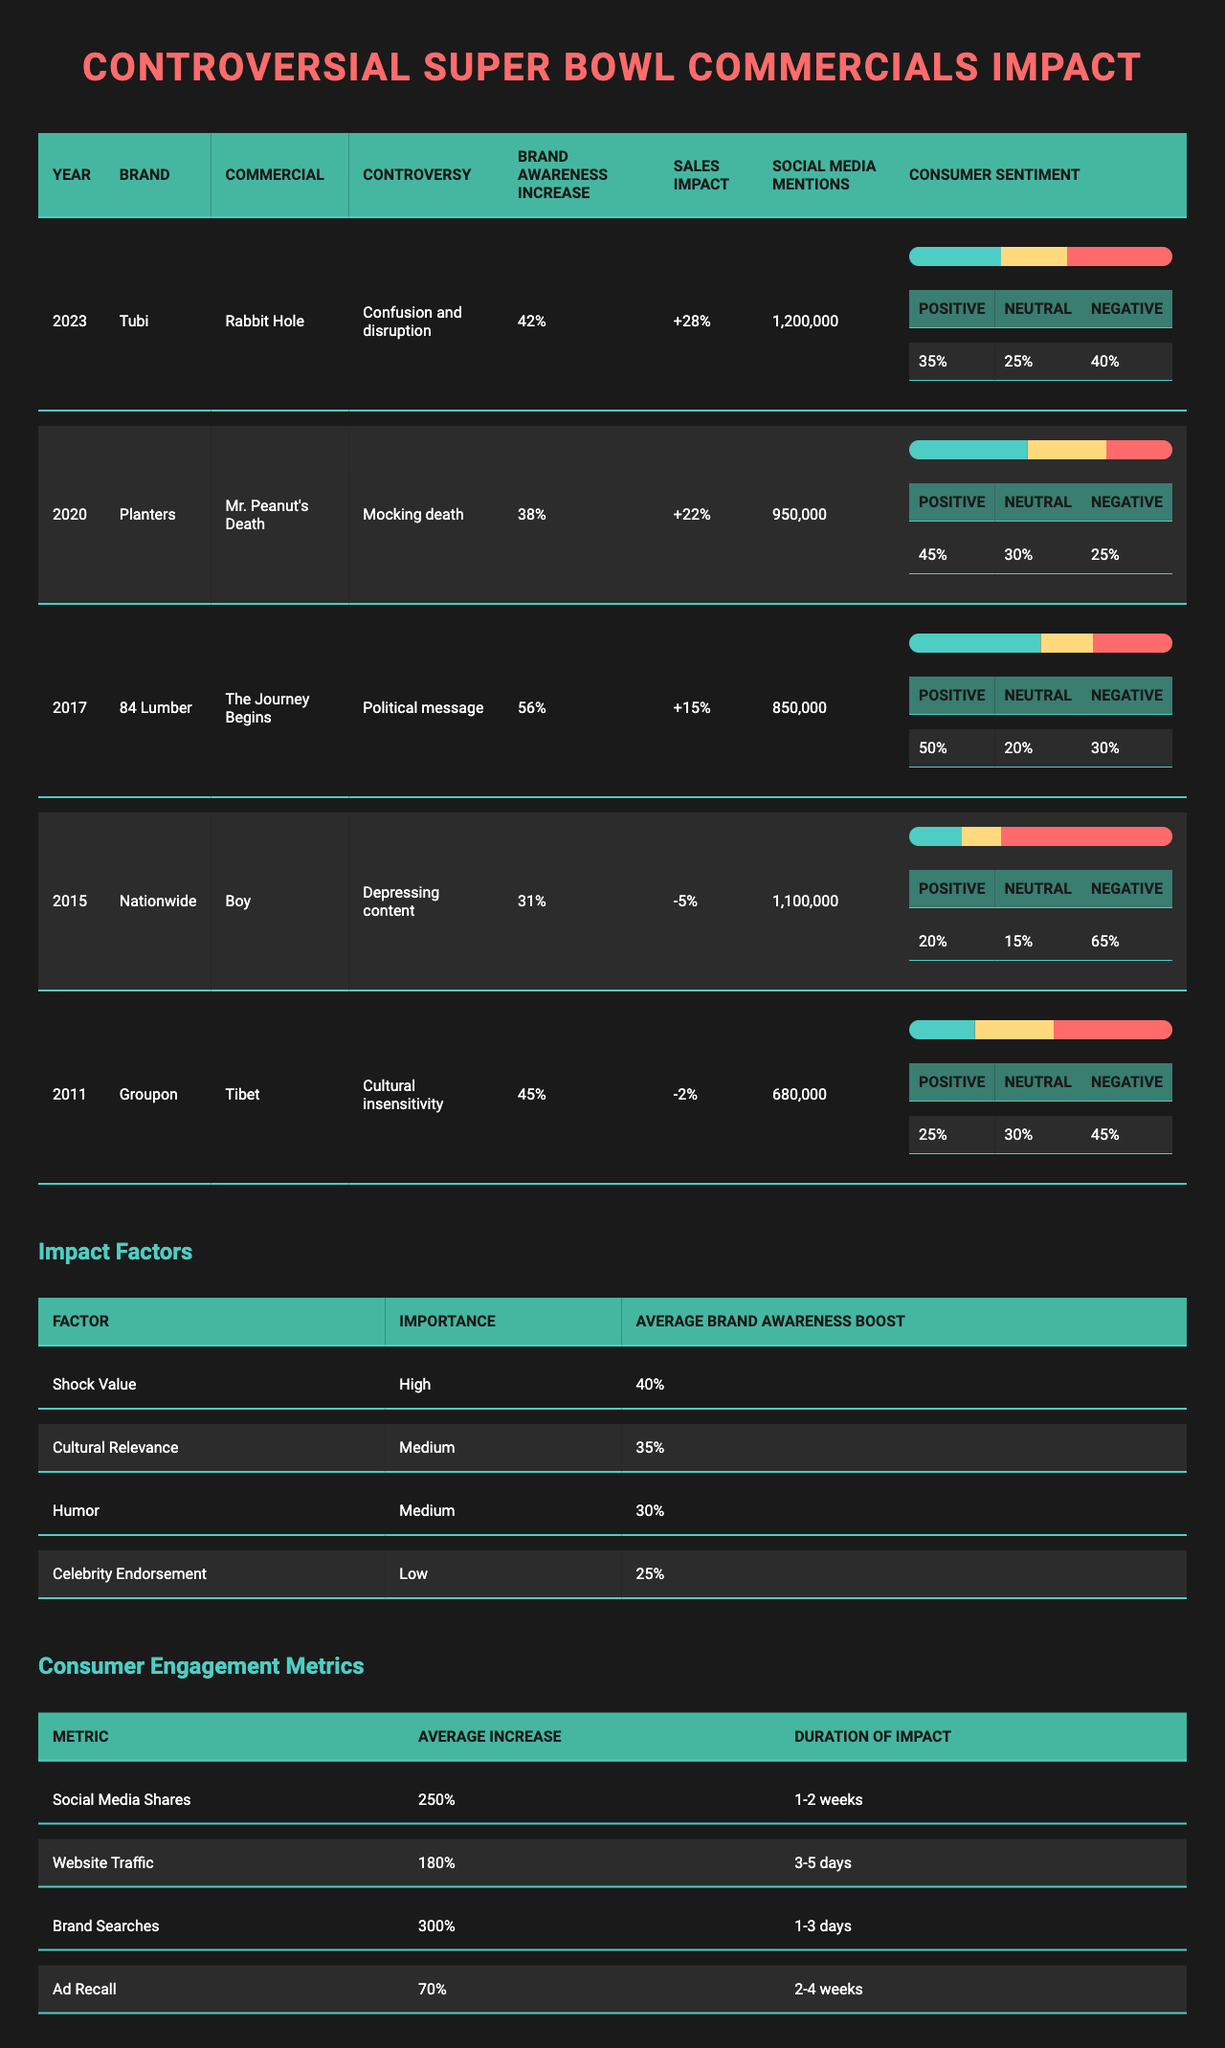What was the brand awareness increase for Tubi's "Rabbit Hole" commercial? The table indicates that Tubi's commercial had a brand awareness increase of 42%.
Answer: 42% Which commercial had the lowest sales impact and what was it? Nationwide's "Boy" commercial had the lowest sales impact at -5%.
Answer: -5% What was the average brand awareness increase of the commercials in 2017? The only commercial listed from 2017 is 84 Lumber's "The Journey Begins," which had a brand awareness increase of 56%.
Answer: 56% Did the "Mr. Peanut's Death" ad by Planters have a positive consumer sentiment higher than 40%? The table shows that Planters' commercial had a positive sentiment of 45%, which is indeed higher than 40%.
Answer: Yes Which commercial had the highest social media mentions and how many were there? Tubi's "Rabbit Hole" commercial had the highest social media mentions, totaling 1,200,000.
Answer: 1,200,000 If we average the sales impacts of all commercials listed, what would that value be? The sales impacts are +28%, +22%, +15%, -5%, and -2%. Summing these gives 28 + 22 + 15 - 5 - 2 = 58, and then dividing by 5 gives an average of 11.6%.
Answer: 11.6% What was the average increase in website traffic as a consumer engagement metric mentioned? The table states that the average increase in website traffic is 180%.
Answer: 180% Which commercial had a decrease in sales and still had a significant brand awareness increase? Nationwide's "Boy" commercial had a sales impact of -5%, while its brand awareness increase was 31%.
Answer: Yes How many commercials had a brand awareness increase greater than 40%? Four commercials had a brand awareness increase greater than 40%: Tubi (42%), Planters (38%), 84 Lumber (56%), and Groupon (45%).
Answer: 3 What was the relationship between controversy type and consumer sentiment for the "Tibet" ad by Groupon? The controversy for Groupon's commercial was cultural insensitivity, and the consumer sentiment was 25% positive, 30% neutral, and 45% negative, indicating a negative overall sentiment.
Answer: Negative overall sentiment 